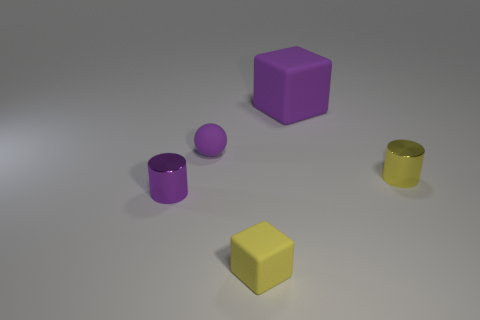There is a matte block that is the same color as the tiny sphere; what is its size?
Keep it short and to the point. Large. Are there any other things that have the same size as the purple cube?
Offer a terse response. No. What number of tiny cylinders are the same color as the small rubber block?
Ensure brevity in your answer.  1. What number of shiny objects are cylinders or yellow cubes?
Provide a short and direct response. 2. There is a ball that is the same color as the big matte block; what material is it?
Make the answer very short. Rubber. Do the rubber sphere and the purple cube have the same size?
Your answer should be very brief. No. What number of objects are tiny gray rubber objects or purple objects that are in front of the big object?
Offer a terse response. 2. What is the material of the purple sphere that is the same size as the yellow matte block?
Offer a terse response. Rubber. The object that is both left of the tiny cube and in front of the yellow shiny cylinder is made of what material?
Your answer should be very brief. Metal. There is a matte block behind the yellow metal cylinder; are there any large things that are in front of it?
Make the answer very short. No. 